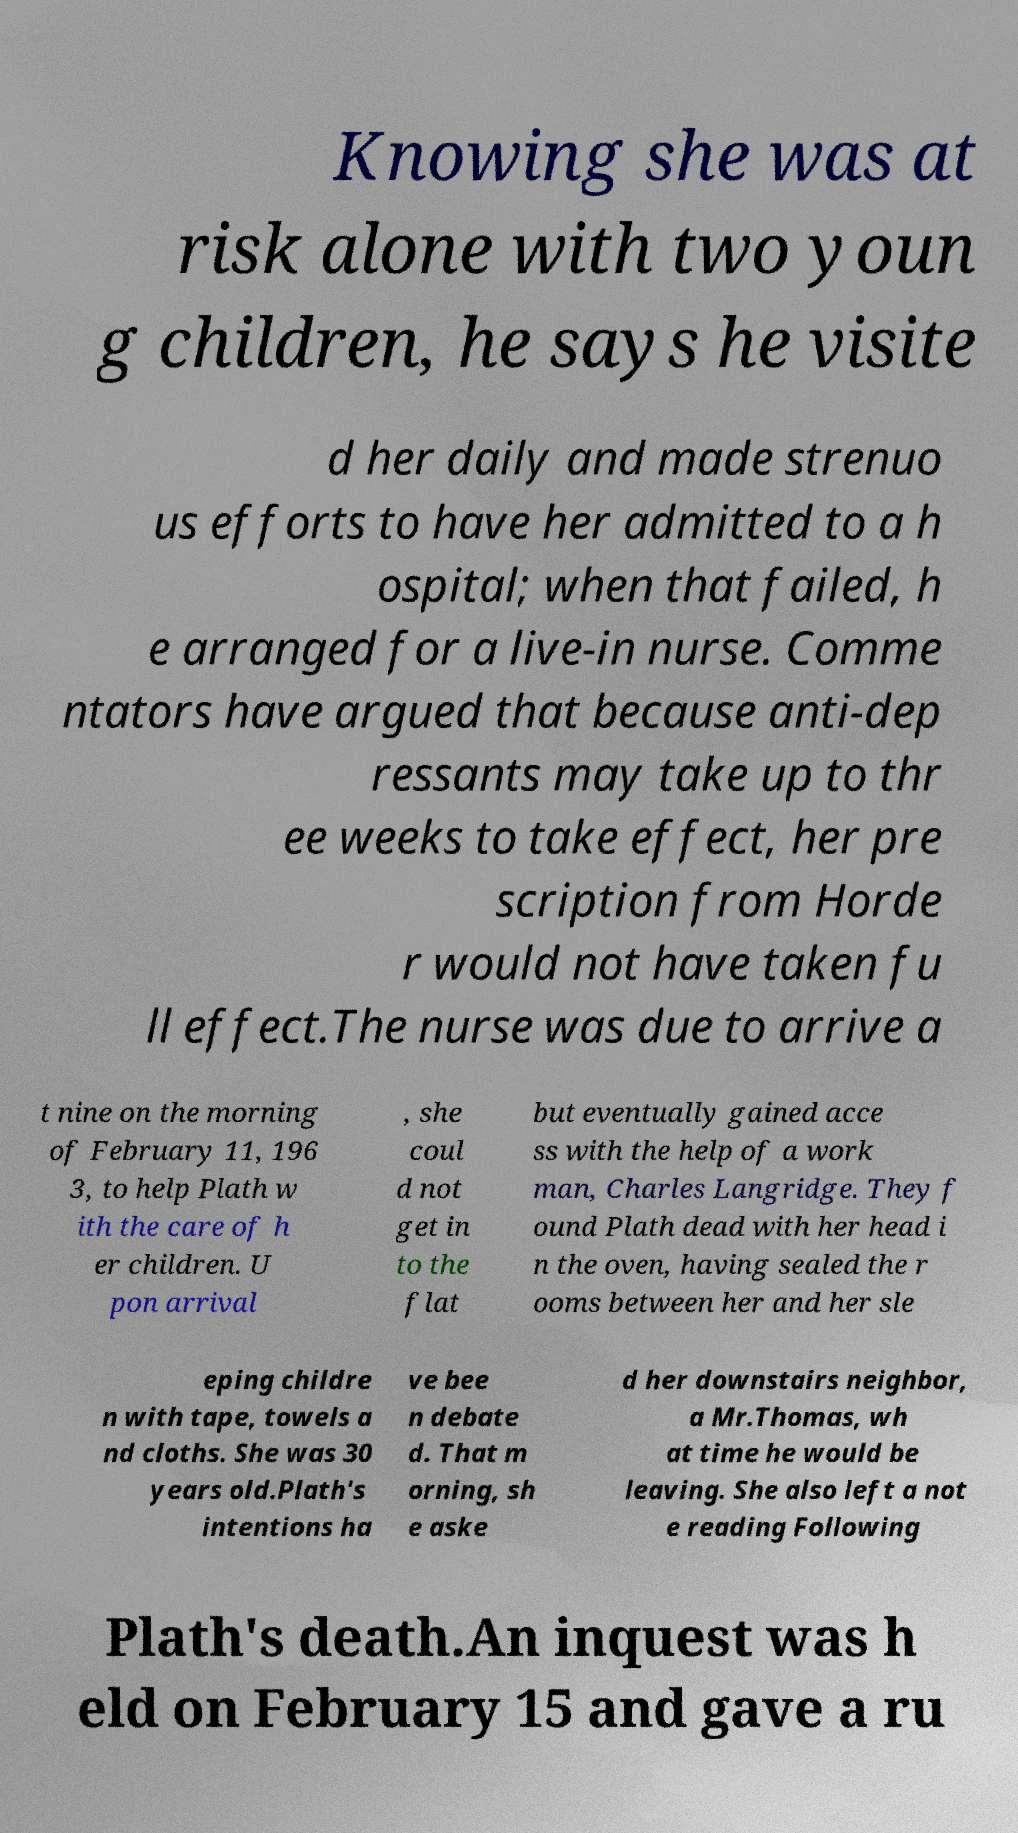Could you assist in decoding the text presented in this image and type it out clearly? Knowing she was at risk alone with two youn g children, he says he visite d her daily and made strenuo us efforts to have her admitted to a h ospital; when that failed, h e arranged for a live-in nurse. Comme ntators have argued that because anti-dep ressants may take up to thr ee weeks to take effect, her pre scription from Horde r would not have taken fu ll effect.The nurse was due to arrive a t nine on the morning of February 11, 196 3, to help Plath w ith the care of h er children. U pon arrival , she coul d not get in to the flat but eventually gained acce ss with the help of a work man, Charles Langridge. They f ound Plath dead with her head i n the oven, having sealed the r ooms between her and her sle eping childre n with tape, towels a nd cloths. She was 30 years old.Plath's intentions ha ve bee n debate d. That m orning, sh e aske d her downstairs neighbor, a Mr.Thomas, wh at time he would be leaving. She also left a not e reading Following Plath's death.An inquest was h eld on February 15 and gave a ru 